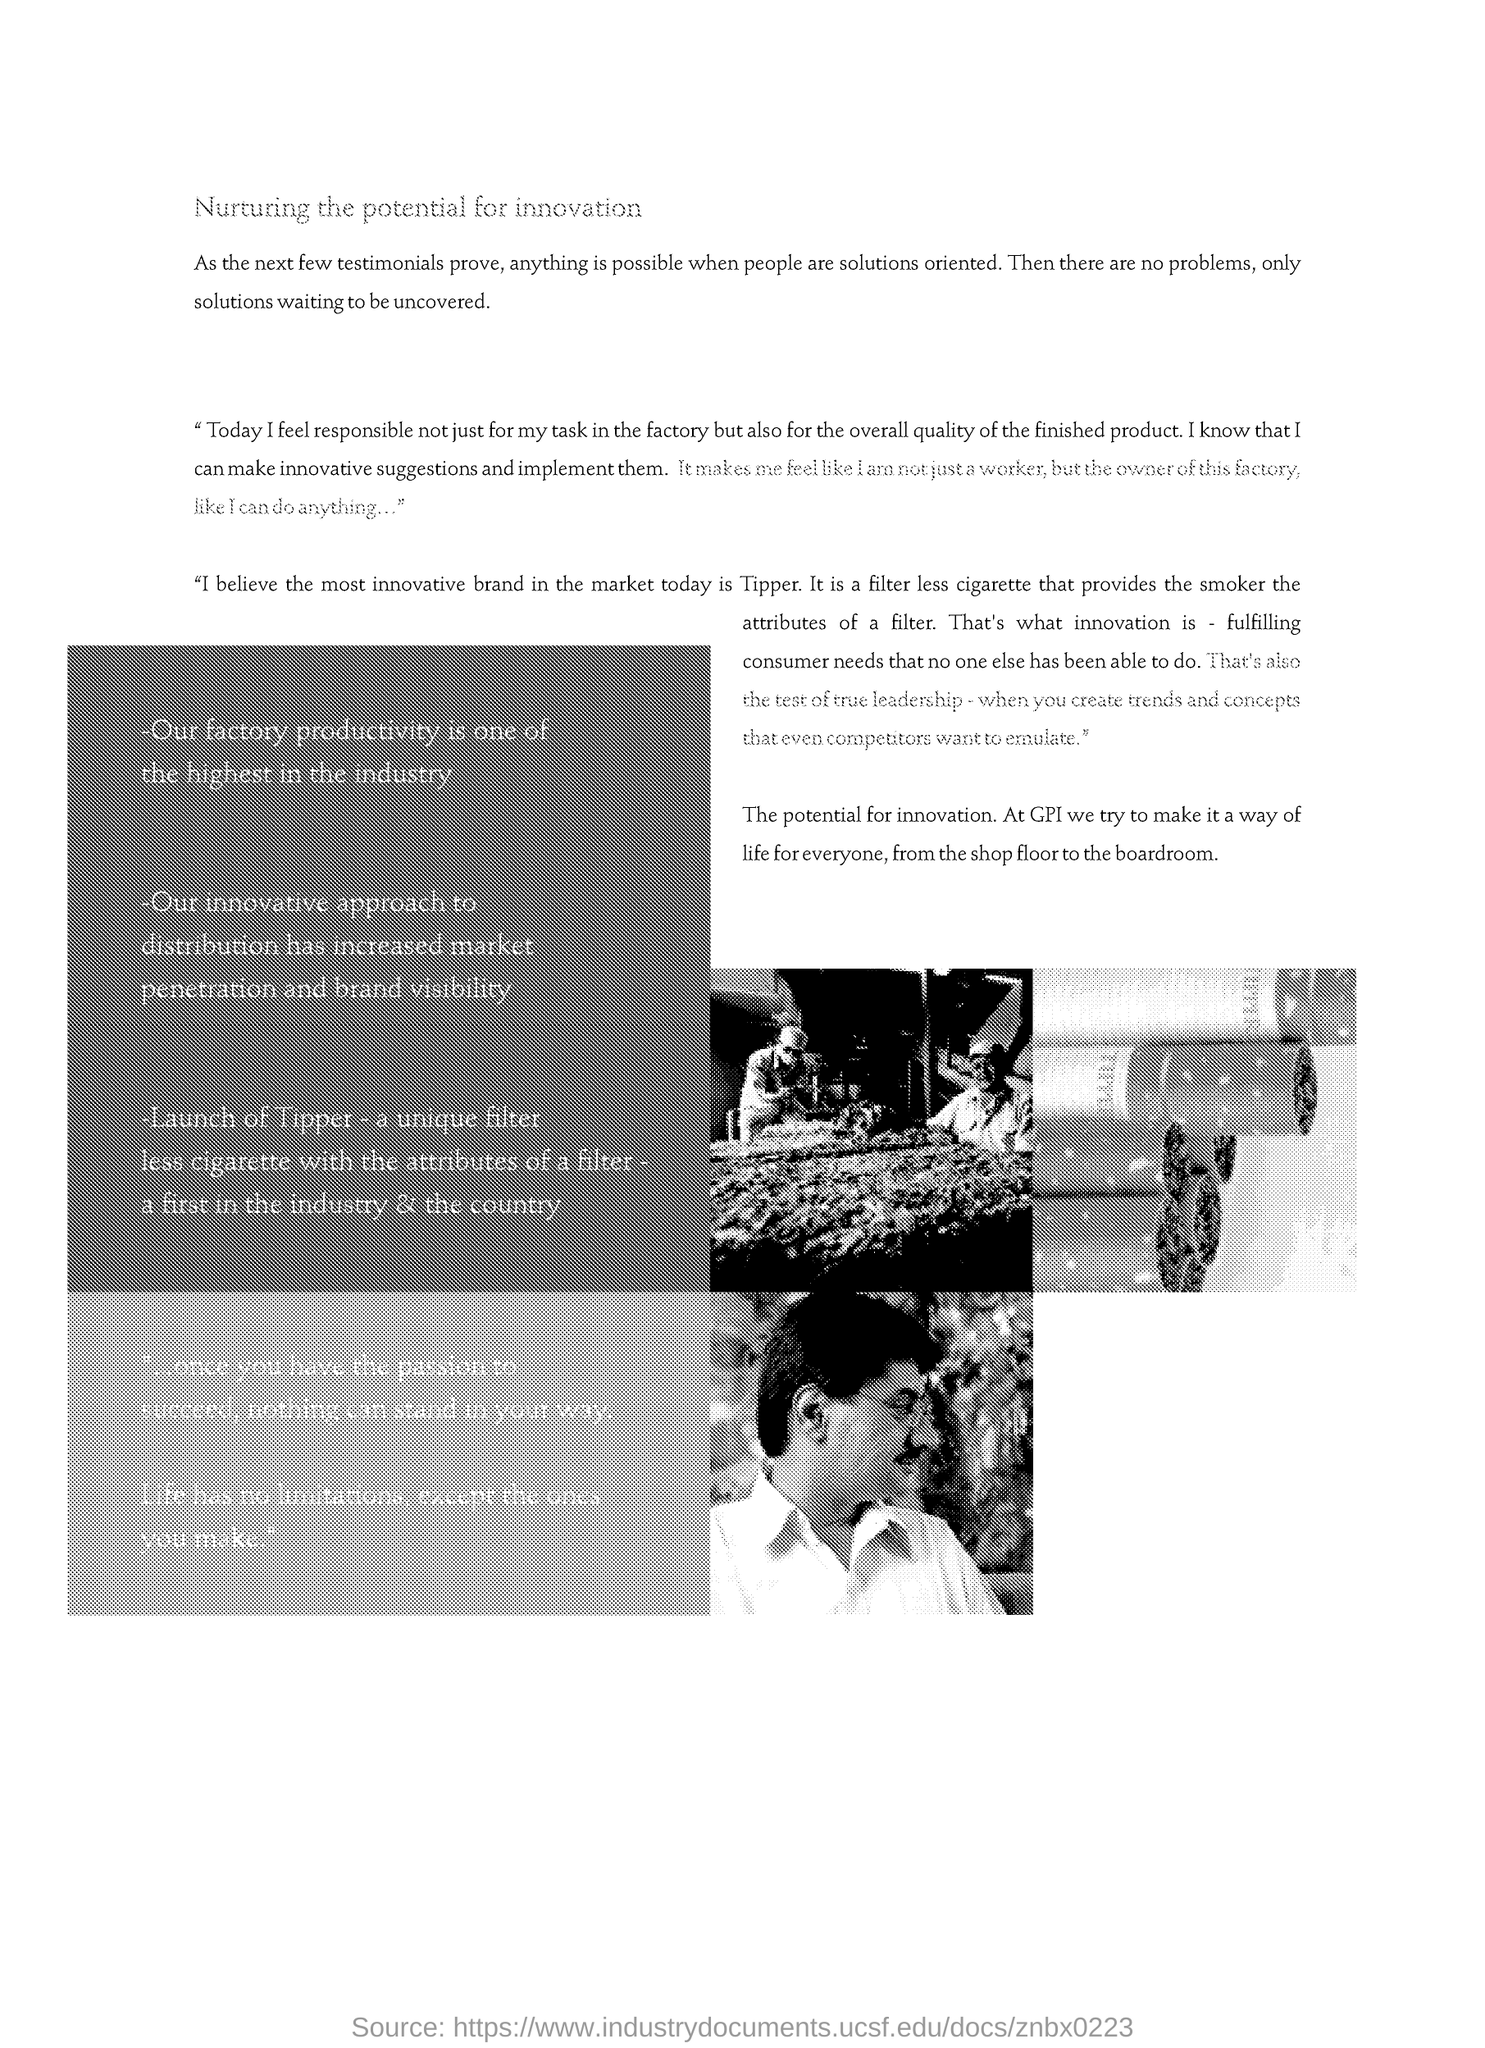Draw attention to some important aspects in this diagram. Tipper is the most innovative brand in the market today. GPI has made innovation a way of life. 